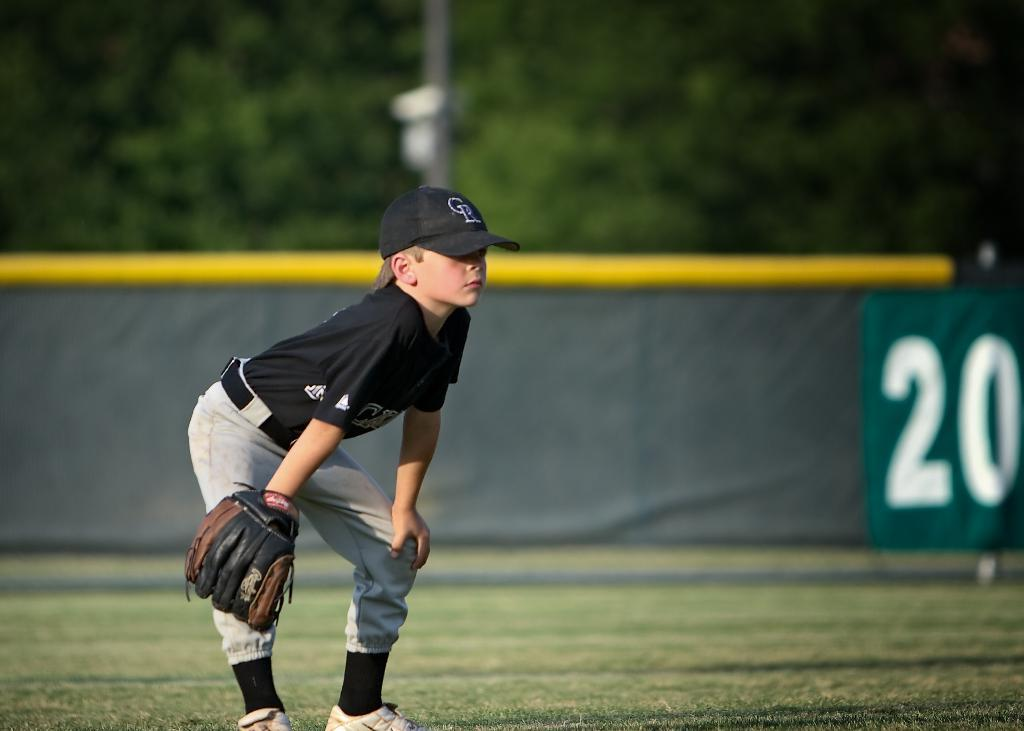<image>
Offer a succinct explanation of the picture presented. A young boy is playing baseball and the stadium wall behind him says 20. 